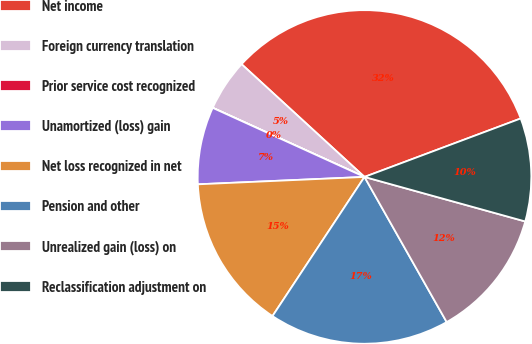Convert chart to OTSL. <chart><loc_0><loc_0><loc_500><loc_500><pie_chart><fcel>Net income<fcel>Foreign currency translation<fcel>Prior service cost recognized<fcel>Unamortized (loss) gain<fcel>Net loss recognized in net<fcel>Pension and other<fcel>Unrealized gain (loss) on<fcel>Reclassification adjustment on<nl><fcel>32.49%<fcel>5.01%<fcel>0.01%<fcel>7.5%<fcel>15.0%<fcel>17.5%<fcel>12.5%<fcel>10.0%<nl></chart> 